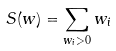Convert formula to latex. <formula><loc_0><loc_0><loc_500><loc_500>S ( w ) = \sum _ { w _ { i } > 0 } w _ { i }</formula> 